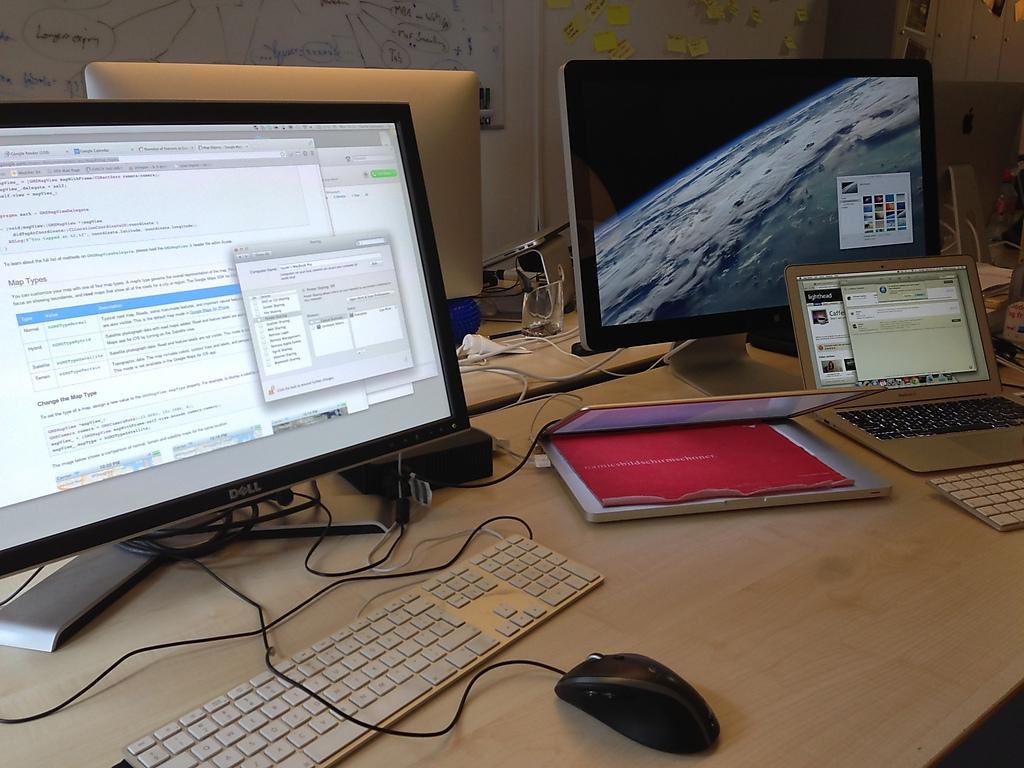<image>
Summarize the visual content of the image. a Dell computer monitor is on a desk with other computers 